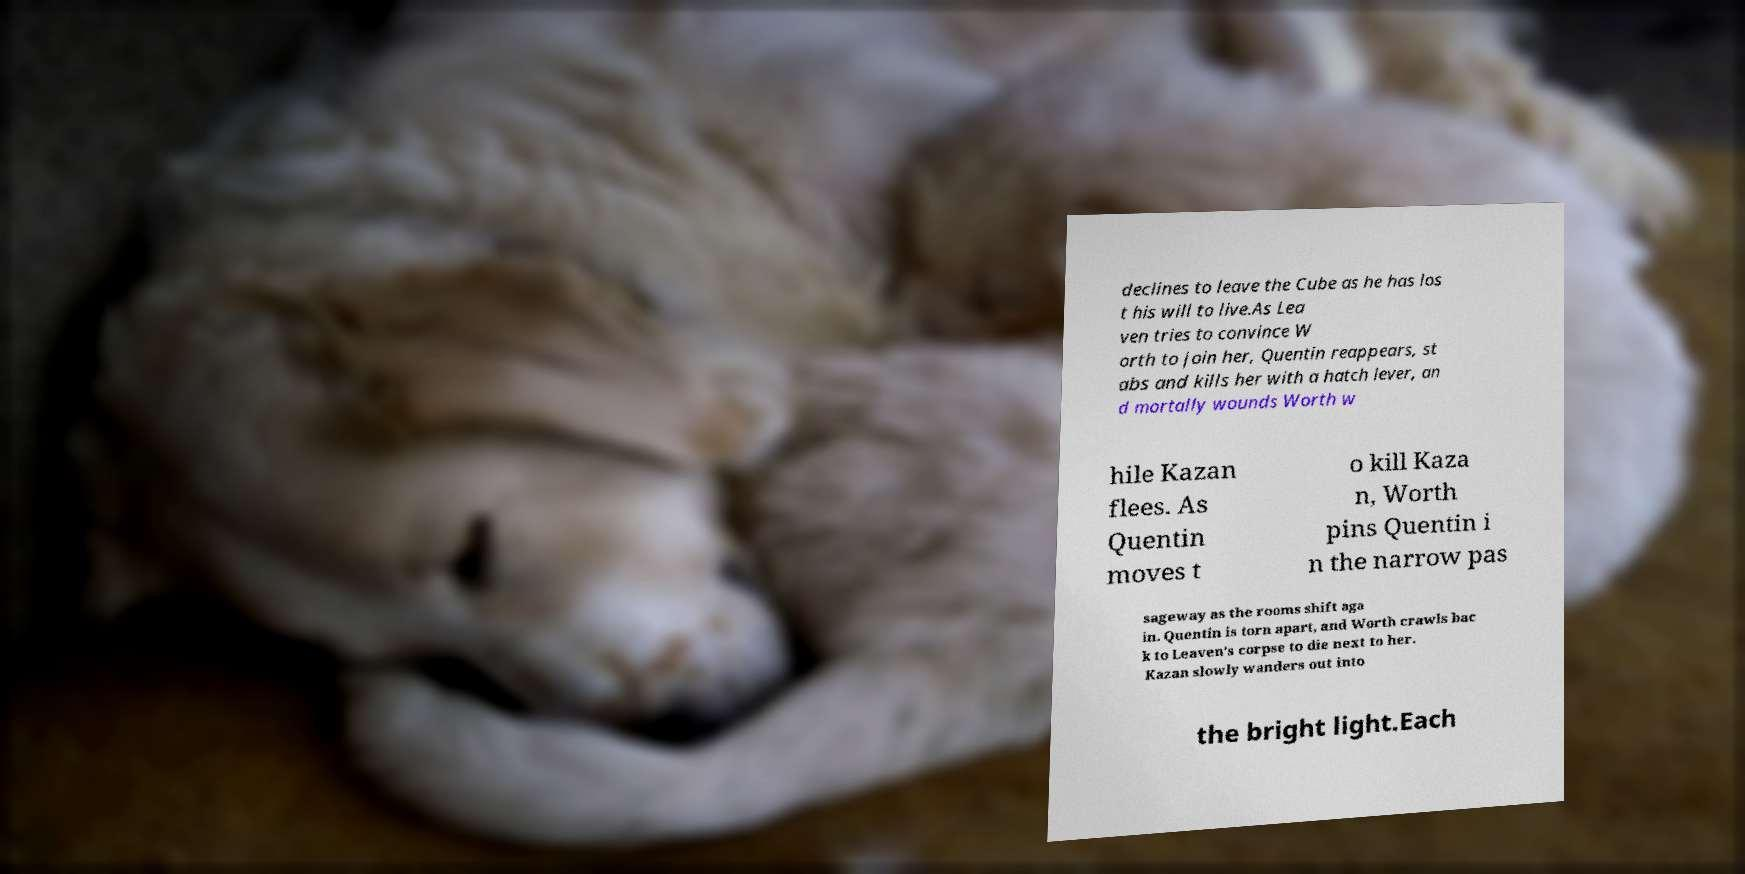I need the written content from this picture converted into text. Can you do that? declines to leave the Cube as he has los t his will to live.As Lea ven tries to convince W orth to join her, Quentin reappears, st abs and kills her with a hatch lever, an d mortally wounds Worth w hile Kazan flees. As Quentin moves t o kill Kaza n, Worth pins Quentin i n the narrow pas sageway as the rooms shift aga in. Quentin is torn apart, and Worth crawls bac k to Leaven's corpse to die next to her. Kazan slowly wanders out into the bright light.Each 